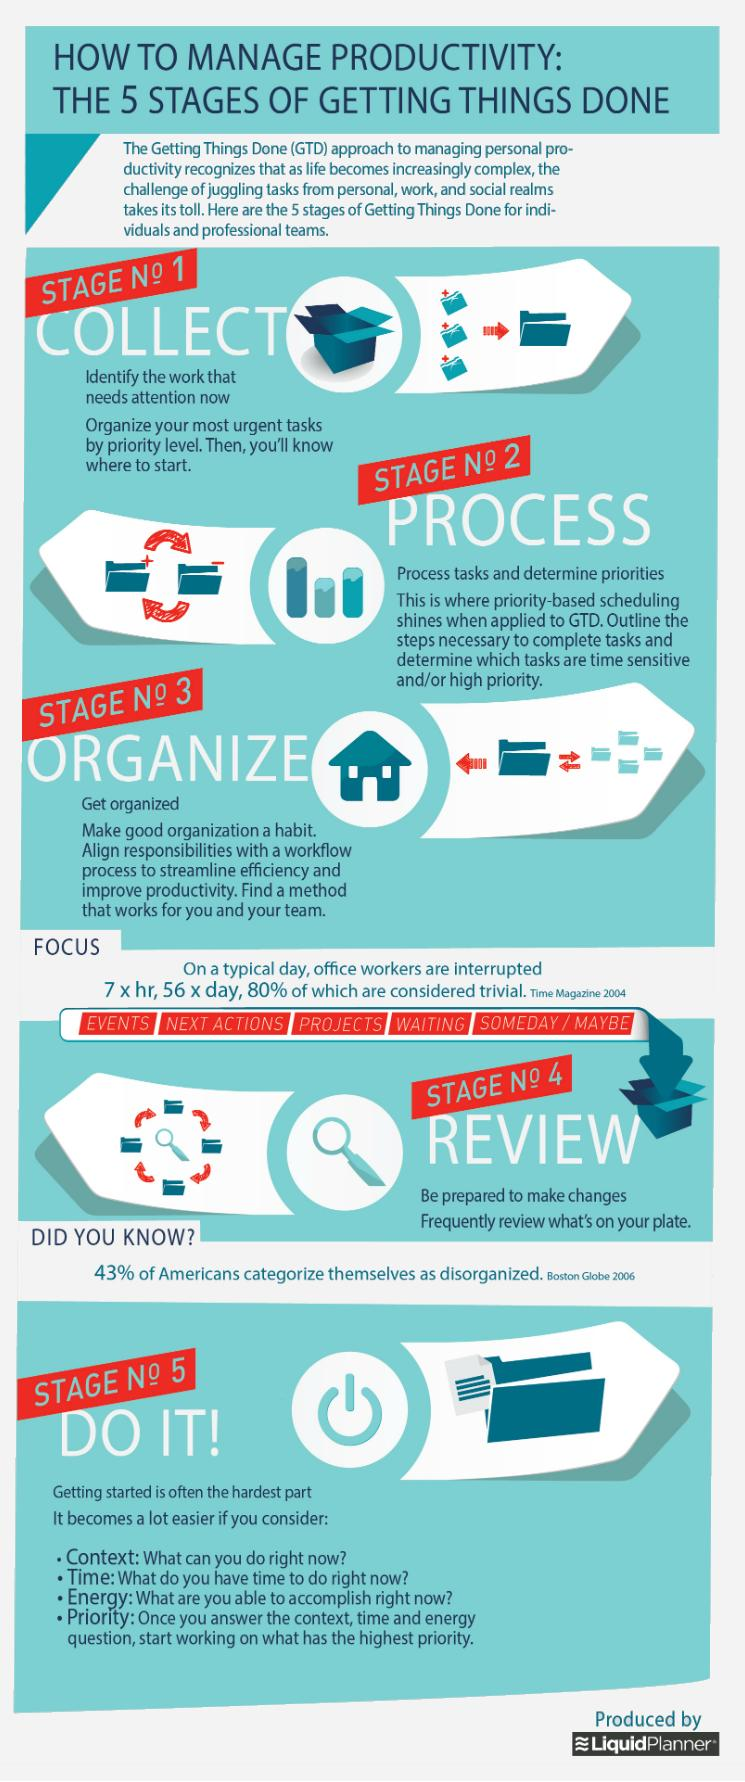Give some essential details in this illustration. Office workers are interrupted an average of 280 times per work week. The context, time, energy, and priority provided make it much easier to get started. 